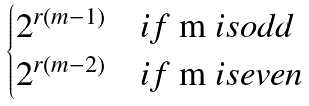<formula> <loc_0><loc_0><loc_500><loc_500>\begin{cases} 2 ^ { r ( m - 1 ) } & i f $ m $ i s o d d \\ 2 ^ { r ( m - 2 ) } & i f $ m $ i s e v e n \end{cases}</formula> 